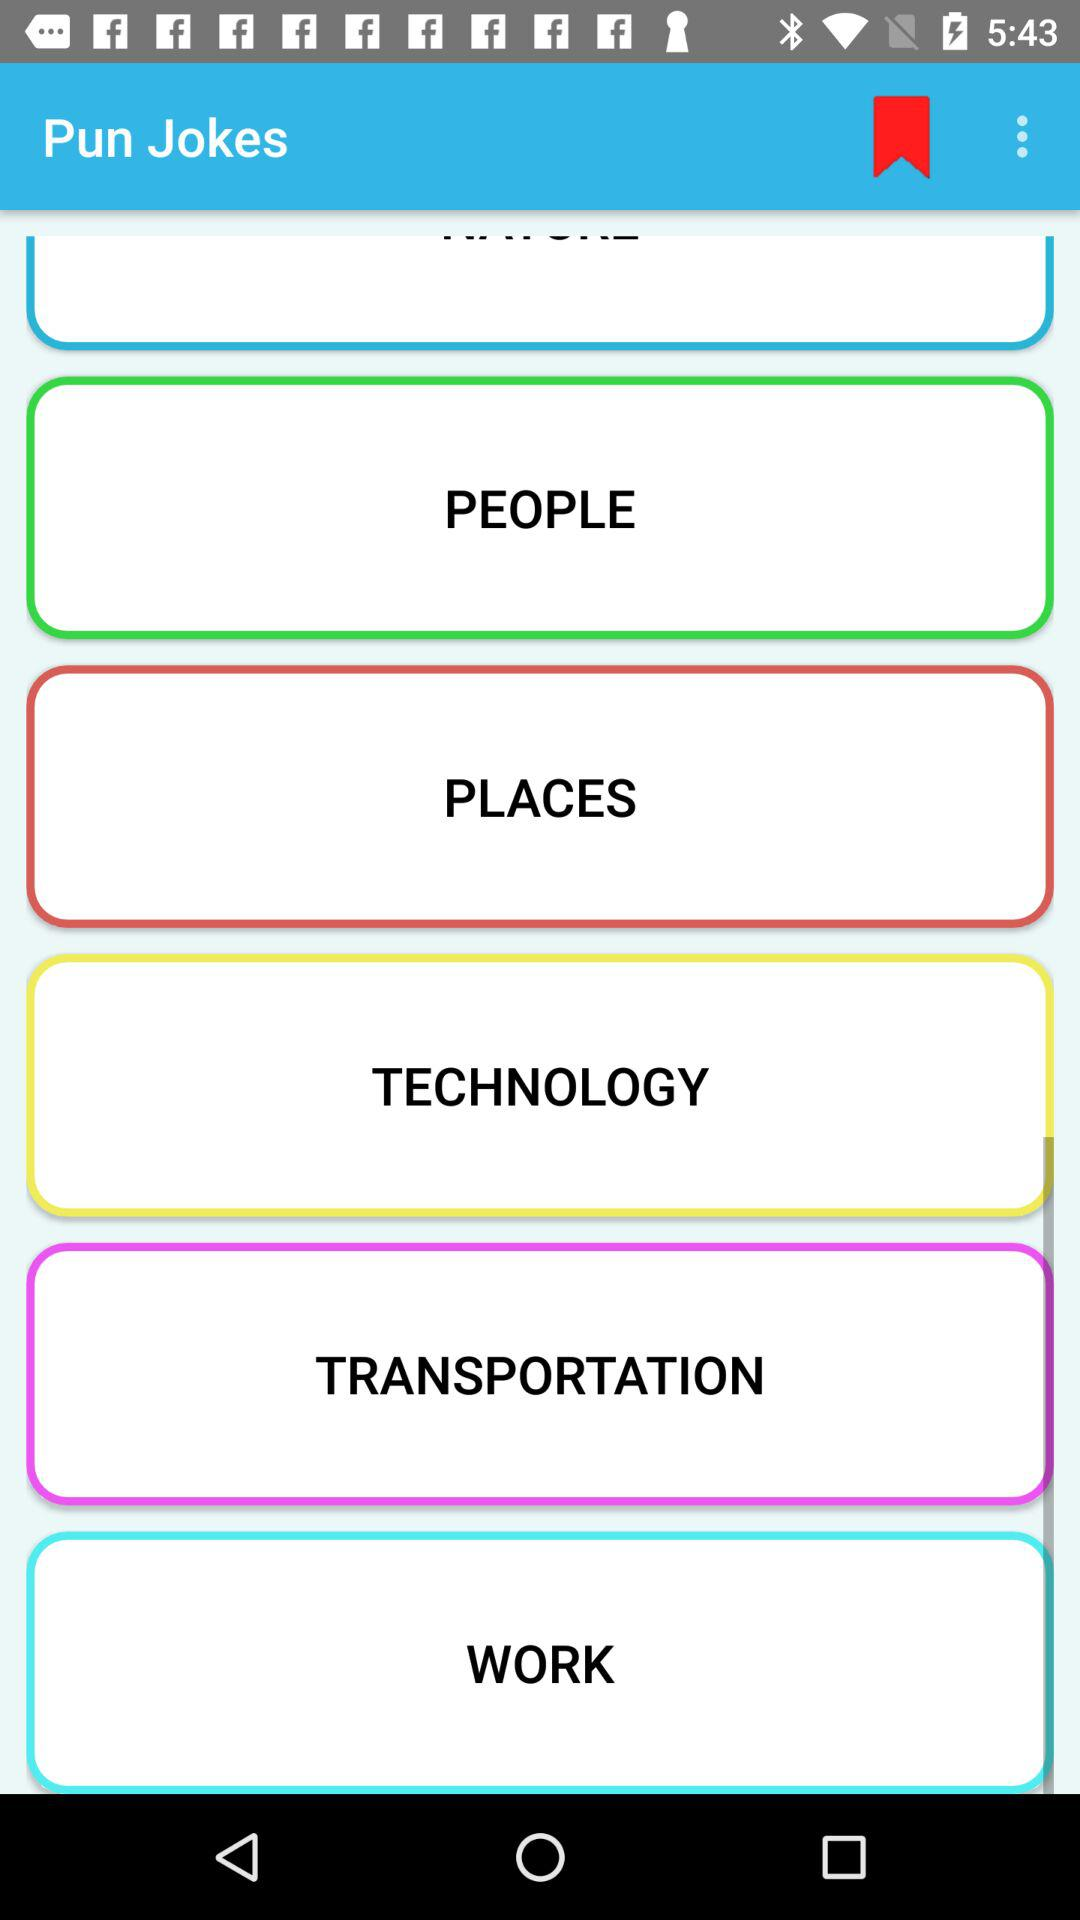What is the app name? The app name is "Pun Jokes". 